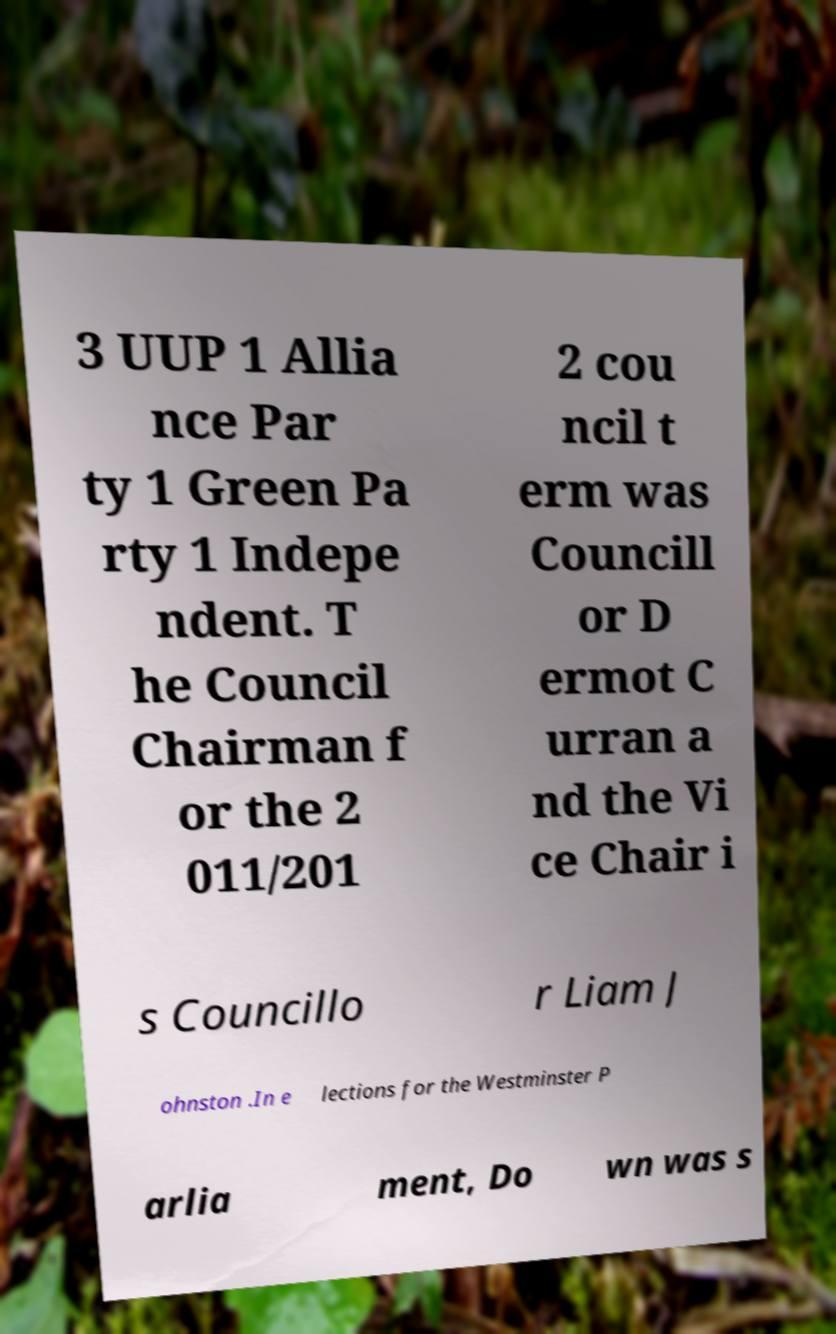For documentation purposes, I need the text within this image transcribed. Could you provide that? 3 UUP 1 Allia nce Par ty 1 Green Pa rty 1 Indepe ndent. T he Council Chairman f or the 2 011/201 2 cou ncil t erm was Councill or D ermot C urran a nd the Vi ce Chair i s Councillo r Liam J ohnston .In e lections for the Westminster P arlia ment, Do wn was s 